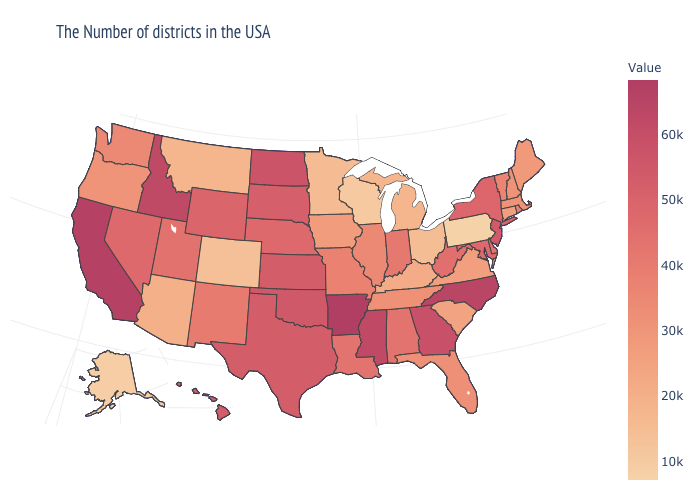Which states have the lowest value in the USA?
Short answer required. Pennsylvania. Among the states that border New York , does Connecticut have the lowest value?
Quick response, please. No. Among the states that border Illinois , does Indiana have the highest value?
Write a very short answer. Yes. Among the states that border North Carolina , which have the lowest value?
Keep it brief. South Carolina. 